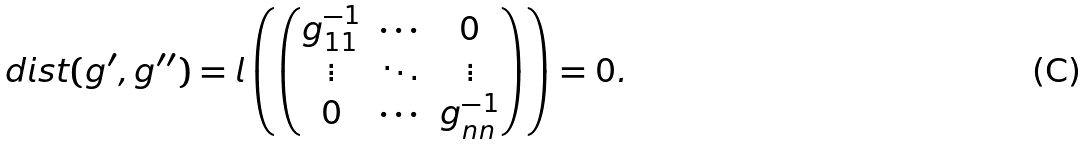Convert formula to latex. <formula><loc_0><loc_0><loc_500><loc_500>d i s t ( g ^ { \prime } , g ^ { \prime \prime } ) = l \left ( \begin{pmatrix} g _ { 1 1 } ^ { - 1 } & \cdots & 0 \\ \vdots & \ddots & \vdots \\ 0 & \cdots & g _ { n n } ^ { - 1 } \end{pmatrix} \right ) = 0 .</formula> 